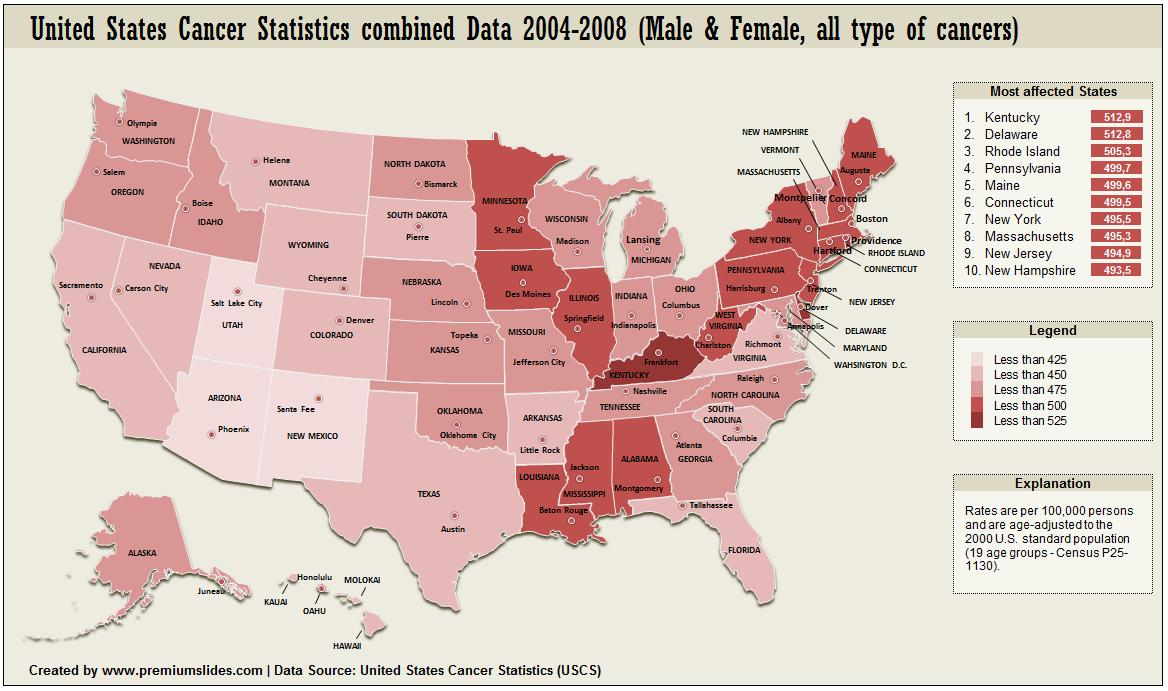Draw attention to some important aspects in this diagram. According to legend, West Virginia has less than 500. It is important to consider both male and female perspectives when studying the topic of sex in statistics. The combined value of Maine and New York is approximately 9951. According to legend, Hawai has less than 450. According to legend, the state of Kentucky has less than 525 of something. 